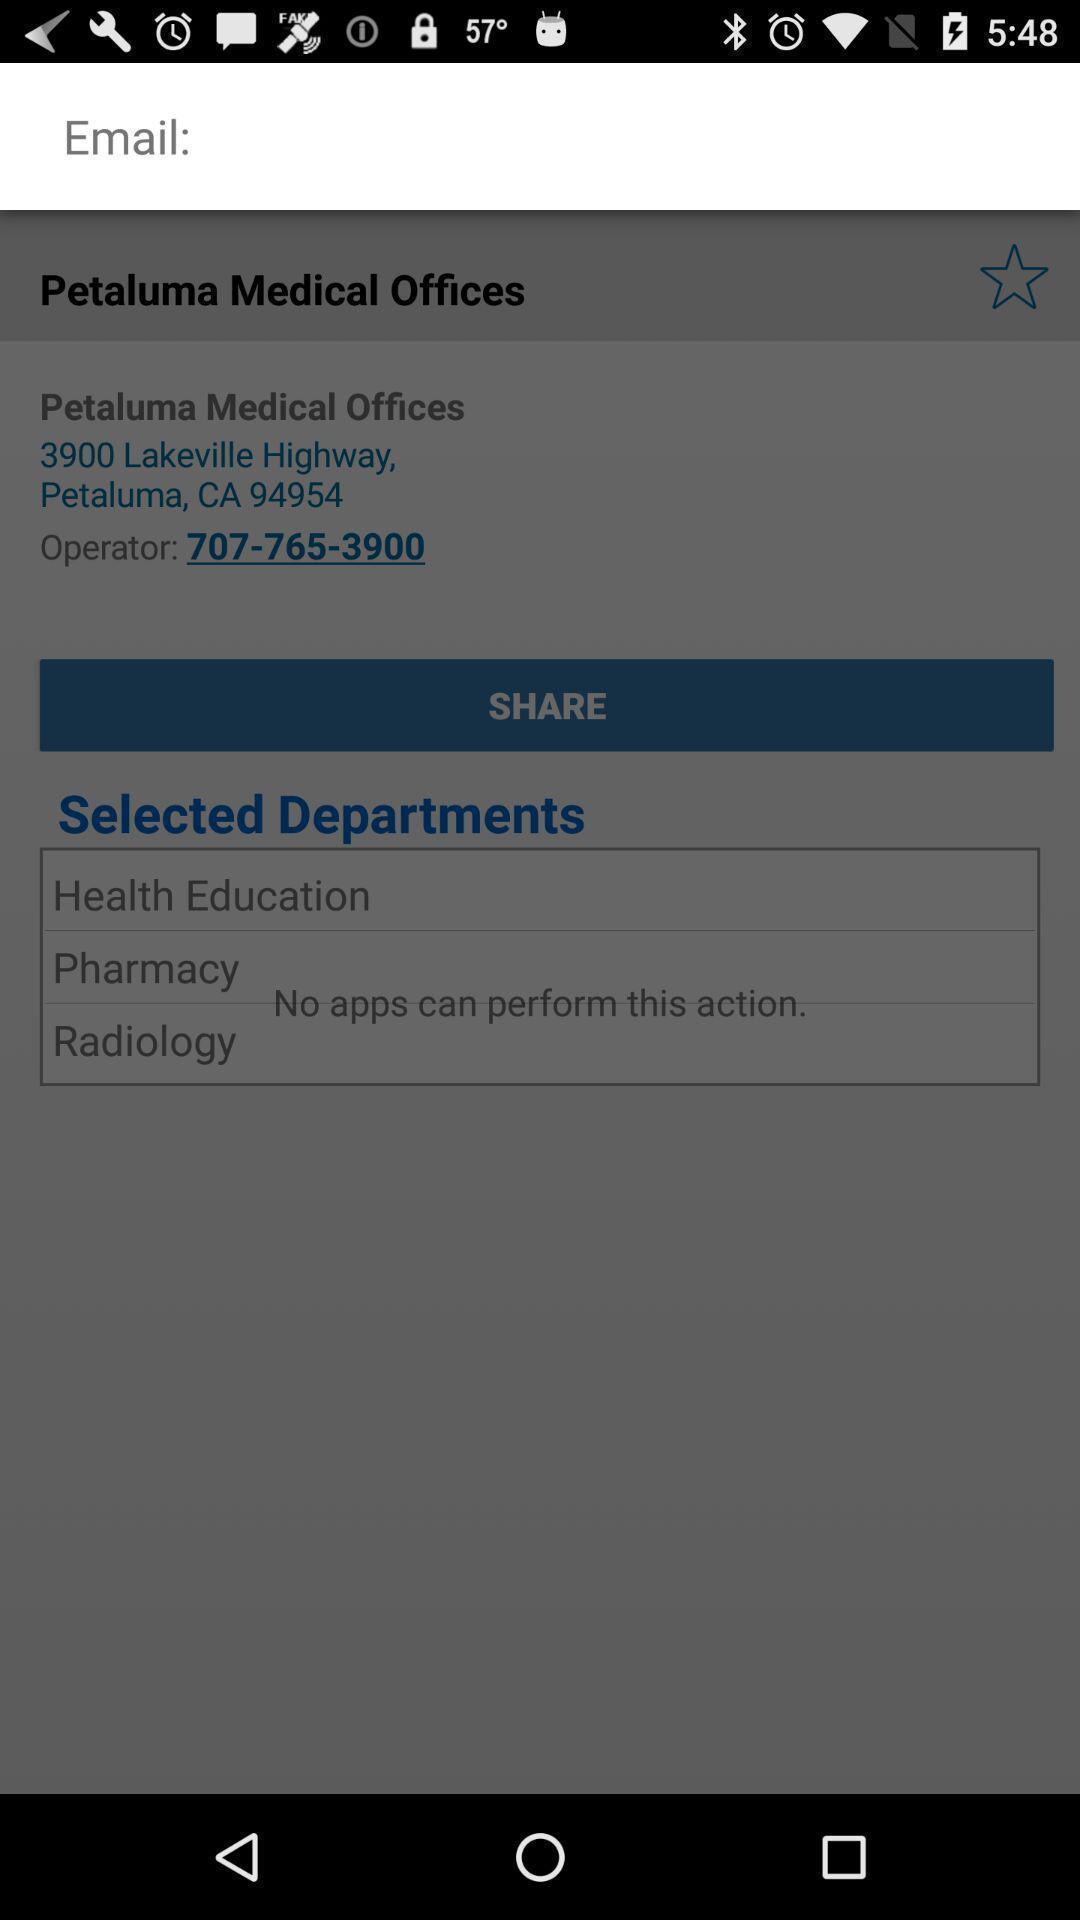Summarize the information in this screenshot. Pop-up asking to enter the email address. 